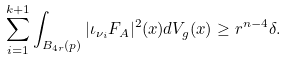<formula> <loc_0><loc_0><loc_500><loc_500>\sum _ { i = 1 } ^ { k + 1 } \int _ { B _ { 4 r } ( p ) } | \iota _ { \nu _ { i } } F _ { A } | ^ { 2 } ( x ) d V _ { g } ( x ) \geq r ^ { n - 4 } \delta .</formula> 